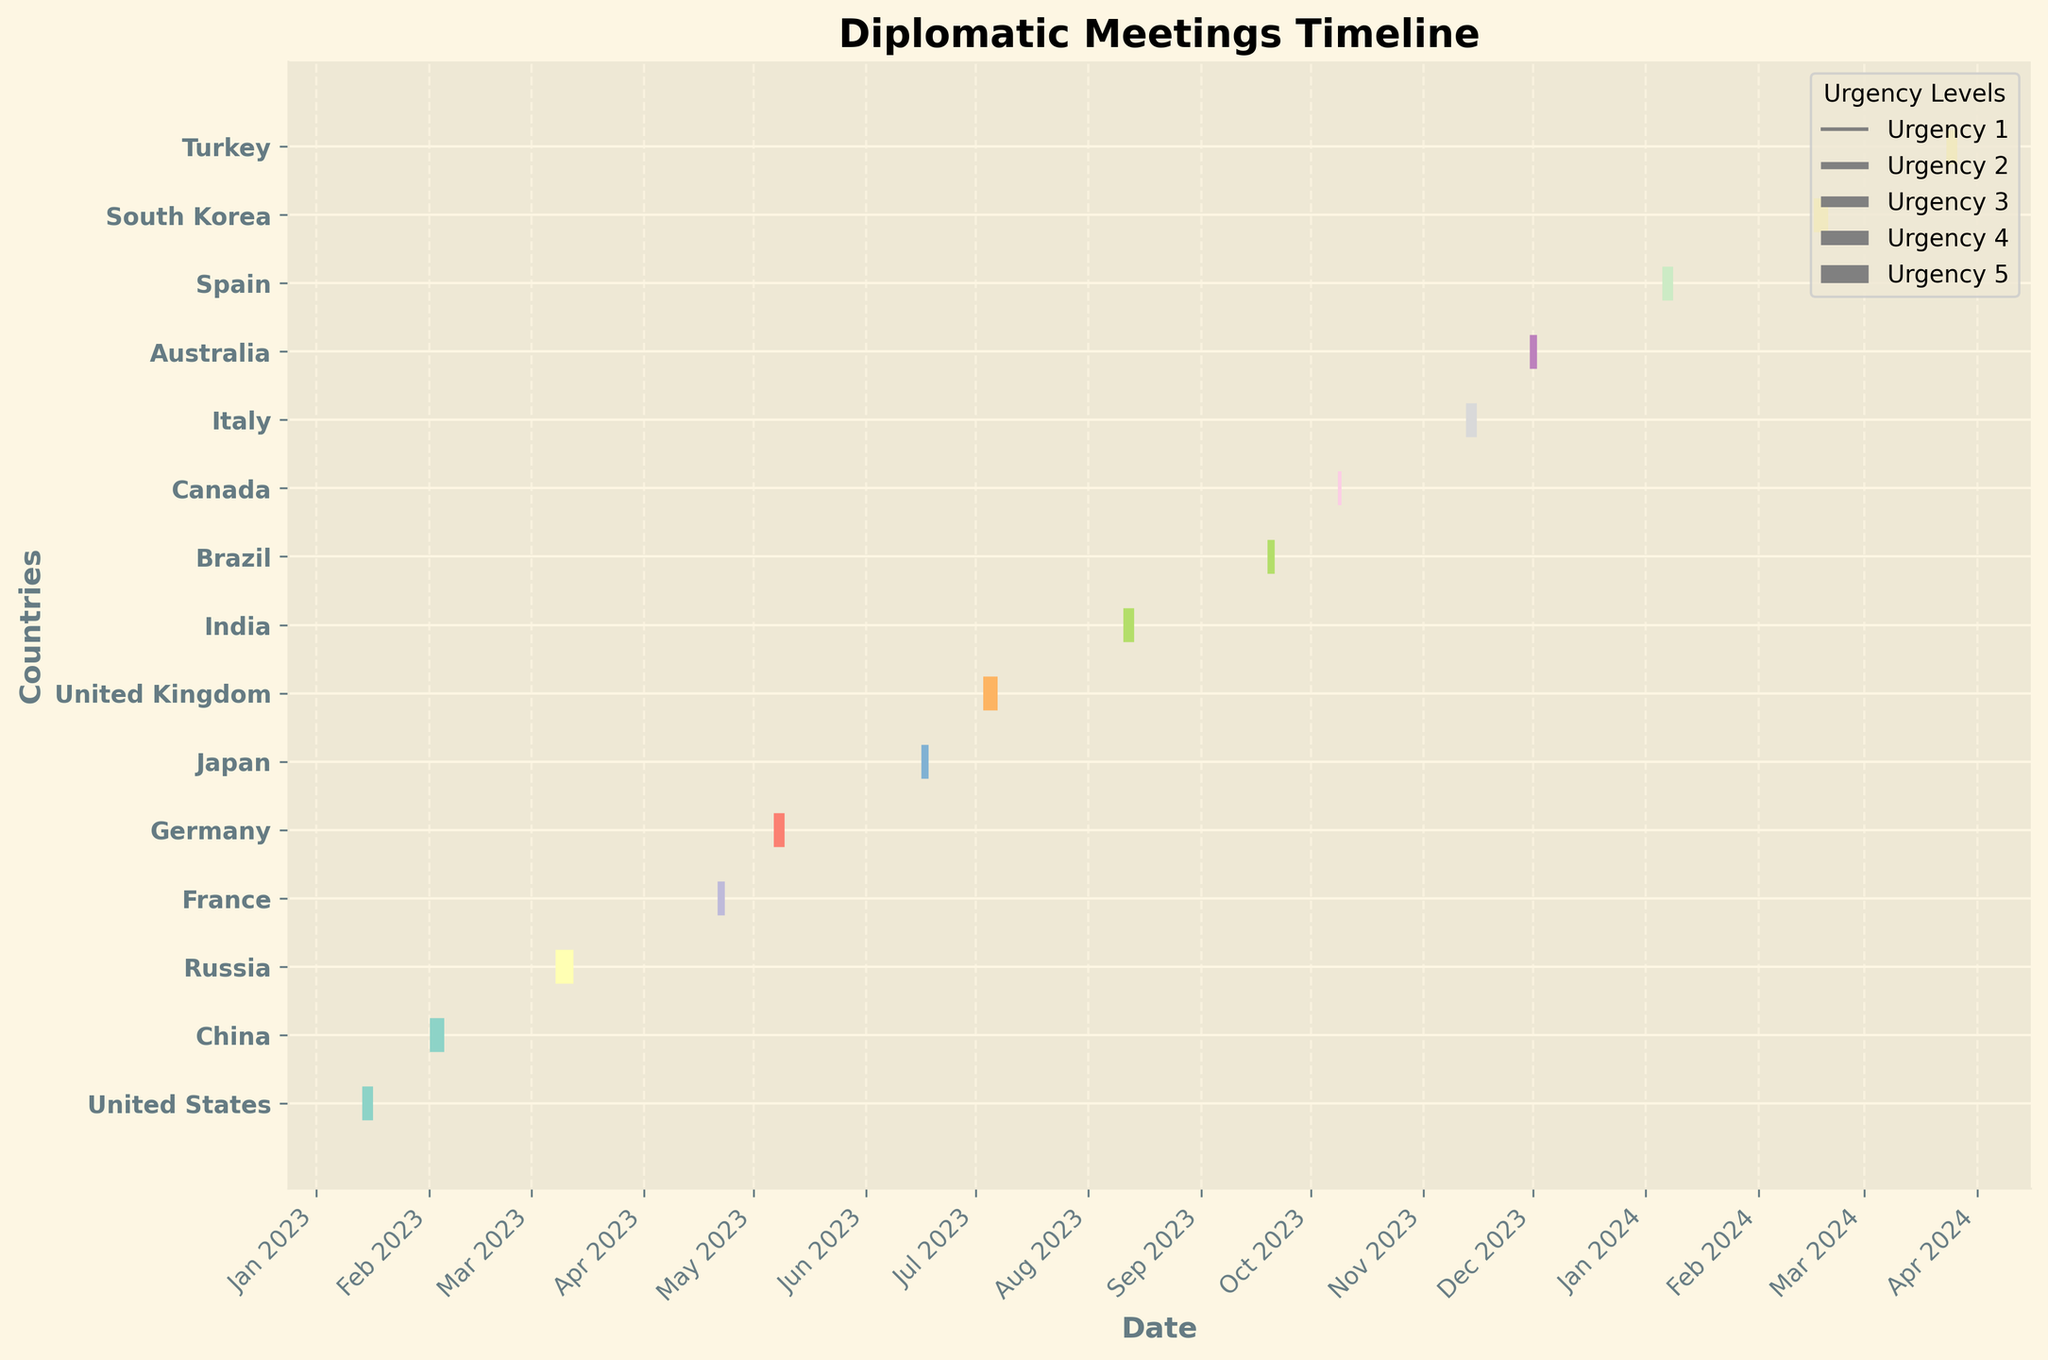what is the title of the plot? The title of the plot is typically placed at the top center of the figure in a larger and bold font, and here it says "Diplomatic Meetings Timeline."
Answer: Diplomatic Meetings Timeline Which country has the meeting with the highest urgency level, and when is it scheduled? The urgency level is represented by the thickness of the lines in the event plot. The thickest line represents the highest urgency level of 5. The country corresponding to the thickest line is Russia, and the meeting is scheduled for March 10, 2023.
Answer: Russia, March 10, 2023 Which month has the most scheduled meetings across all countries? To find the month with the most scheduled meetings, look for the month that has the highest number of lines plotted. Upon examining the figure, it appears that June 2023 has the highest concentration of lines.
Answer: June 2023 Which country has the earliest scheduled meeting, and what is the urgency level? To determine the earliest meeting, locate the first plotted line along the x-axis. The earliest meeting is scheduled for January 15, 2023, and it is associated with the United States. The urgency level of this meeting is represented by the thickness of the line, which corresponds to 3.
Answer: United States, Urgency 3 How many countries have their meetings scheduled in the second half of 2023? To find the countries with meetings in the second half of 2023, examine the x-axis from July to December 2023. Identify the corresponding y-axis labels. The countries are United Kingdom, India, Brazil, Canada, and Australia, which sum up to 5 countries.
Answer: 5 countries Which two countries have meetings with urgency level 4, and what are their scheduled dates? Meetings with urgency level 4 are identified by relatively thick lines. The two countries with these thicknesses are China (February 3, 2023) and United Kingdom (July 5, 2023).
Answer: China (February 3, 2023), United Kingdom (July 5, 2023) Are there any countries with multiple scheduled meetings? By checking the y-axis labels (countries) and tracing each country to its corresponding line on the x-axis, you can confirm that each country has only one scheduled meeting in the timeline.
Answer: No What is the median urgency level of the meetings? To find the median urgency level, list all the urgency values and determine the middle value. The urgency values are 3, 4, 5, 2, 3, 2, 4, 3, 2, 1, 3, 2, 3, 4, 3. Sorting them gives 1, 2, 2, 2, 2, 3, 3, 3, 3, 3, 3, 4, 4, 4, 5. The median is the 8th value, which is 3.
Answer: 3 